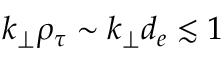Convert formula to latex. <formula><loc_0><loc_0><loc_500><loc_500>k _ { \perp } \rho _ { \tau } \sim k _ { \perp } d _ { e } \lesssim 1</formula> 